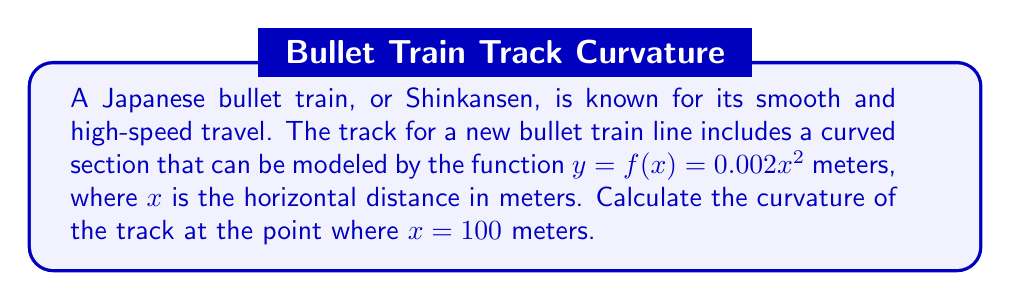Give your solution to this math problem. To find the curvature of the track, we'll use the curvature formula for a function $y = f(x)$:

$$ \kappa = \frac{|f''(x)|}{(1 + [f'(x)]^2)^{3/2}} $$

Let's break this down step-by-step:

1) First, we need to find $f'(x)$ and $f''(x)$:
   $f(x) = 0.002x^2$
   $f'(x) = 0.004x$
   $f''(x) = 0.004$

2) Now, let's evaluate $f'(x)$ at $x = 100$:
   $f'(100) = 0.004 \cdot 100 = 0.4$

3) We can now plug these values into the curvature formula:

   $$ \kappa = \frac{|0.004|}{(1 + [0.4]^2)^{3/2}} $$

4) Simplify:
   $$ \kappa = \frac{0.004}{(1 + 0.16)^{3/2}} = \frac{0.004}{1.16^{3/2}} $$

5) Calculate the final result:
   $$ \kappa \approx 0.00332 \text{ m}^{-1} $$

The curvature is approximately 0.00332 per meter, or 3.32 × 10^-3 m^-1.
Answer: The curvature of the track at $x = 100$ meters is approximately 0.00332 m^-1. 